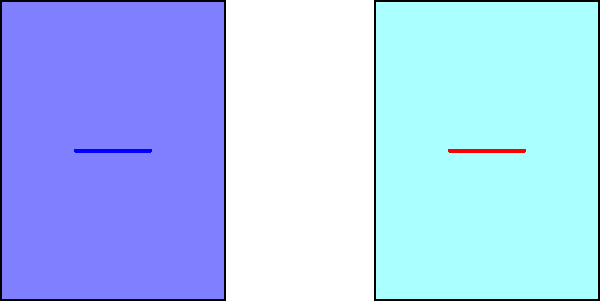In the visual comparison between an original painting and its authorized reproduction, what is the most noticeable difference, and how might this relate to the artist's commitment to originality? To answer this question, we need to analyze the visual representation carefully:

1. The image shows two similar rectangular shapes, labeled "Original" and "Reproduction".
2. Both shapes are predominantly filled with a light blue color.
3. The main difference is in the center of each shape:
   a. In the original, there's a blue horizontal line (labeled A).
   b. In the reproduction, there's a red horizontal line (labeled B).
4. The change in color from blue to red is the most noticeable difference.
5. This color change likely represents a deliberate modification made by the artist in the authorized reproduction.
6. Such a change demonstrates the artist's commitment to originality by:
   a. Ensuring the reproduction is distinguishable from the original.
   b. Adding a unique element to the reproduction, making it valuable in its own right.
   c. Respecting copyright laws by clearly differentiating between original and reproduction.

The color change from blue to red in the central line is the key difference, showcasing the artist's dedication to maintaining originality even in authorized reproductions.
Answer: Color change in central line (blue to red) 